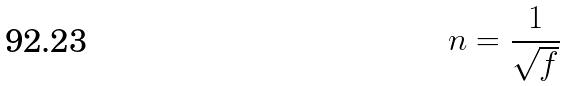Convert formula to latex. <formula><loc_0><loc_0><loc_500><loc_500>n = \frac { 1 } { \sqrt { f } }</formula> 